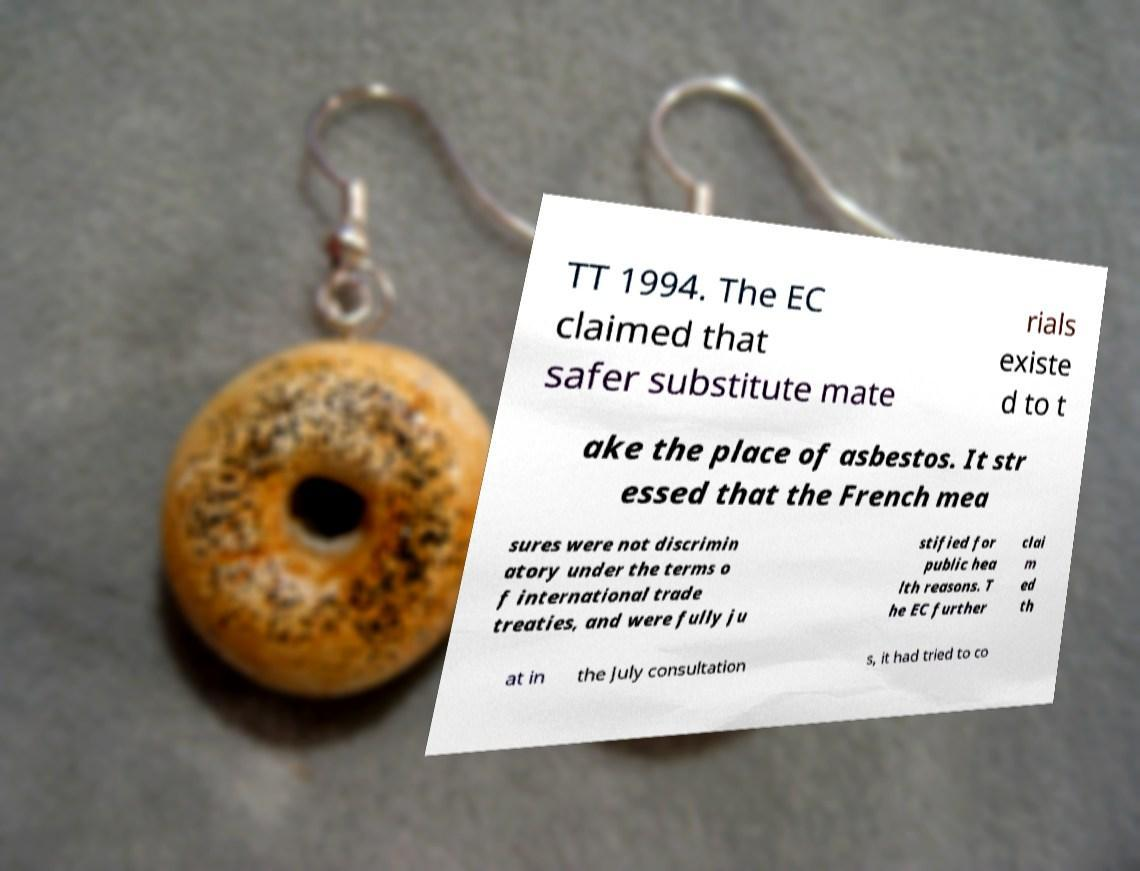Could you assist in decoding the text presented in this image and type it out clearly? TT 1994. The EC claimed that safer substitute mate rials existe d to t ake the place of asbestos. It str essed that the French mea sures were not discrimin atory under the terms o f international trade treaties, and were fully ju stified for public hea lth reasons. T he EC further clai m ed th at in the July consultation s, it had tried to co 